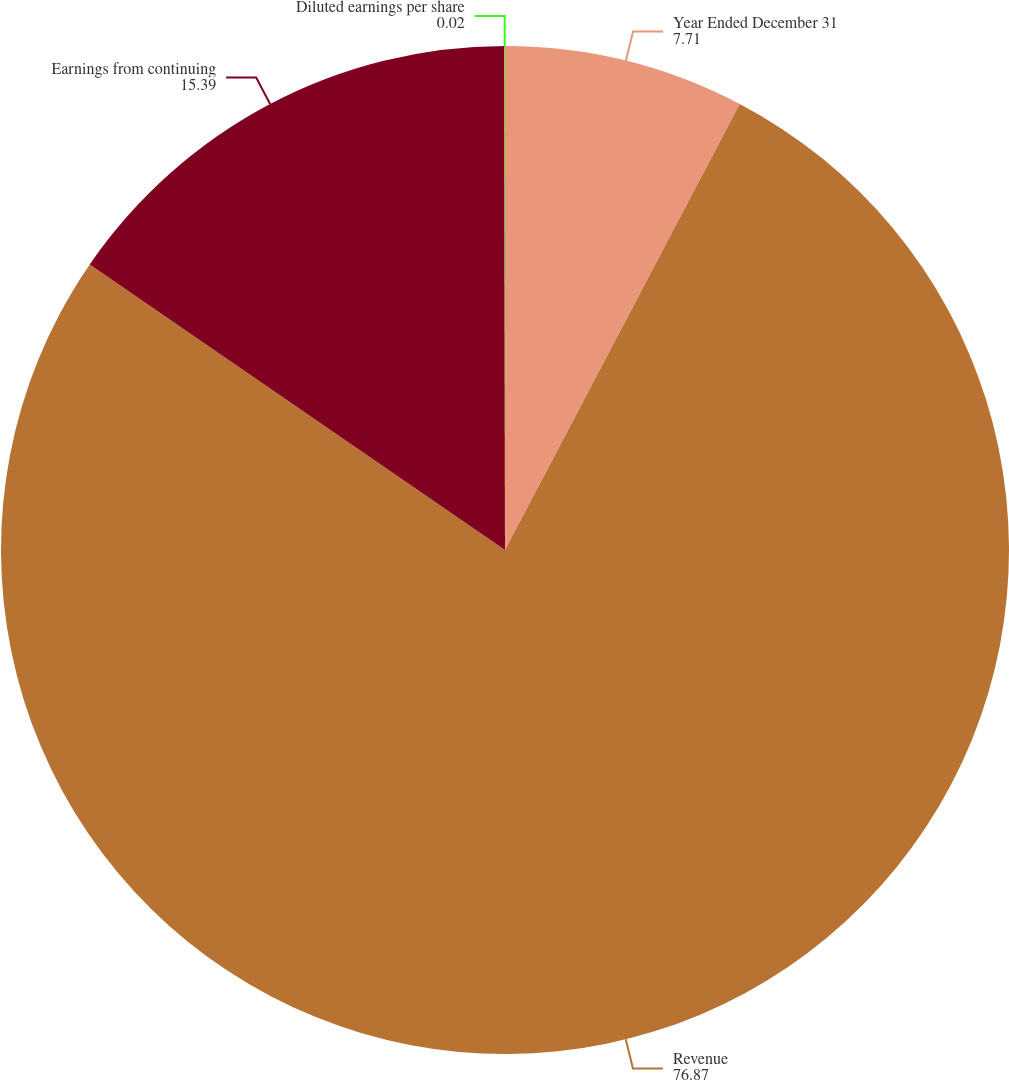<chart> <loc_0><loc_0><loc_500><loc_500><pie_chart><fcel>Year Ended December 31<fcel>Revenue<fcel>Earnings from continuing<fcel>Diluted earnings per share<nl><fcel>7.71%<fcel>76.87%<fcel>15.39%<fcel>0.02%<nl></chart> 